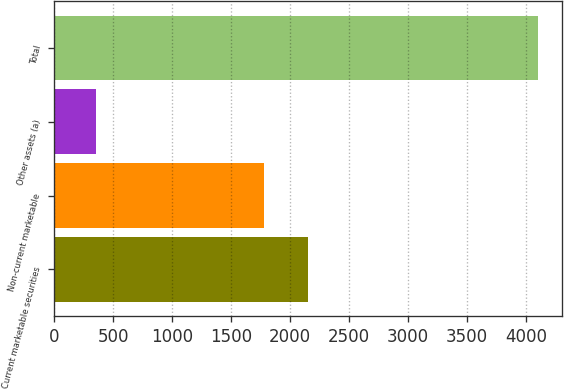Convert chart. <chart><loc_0><loc_0><loc_500><loc_500><bar_chart><fcel>Current marketable securities<fcel>Non-current marketable<fcel>Other assets (a)<fcel>Total<nl><fcel>2149.8<fcel>1775<fcel>354<fcel>4102<nl></chart> 